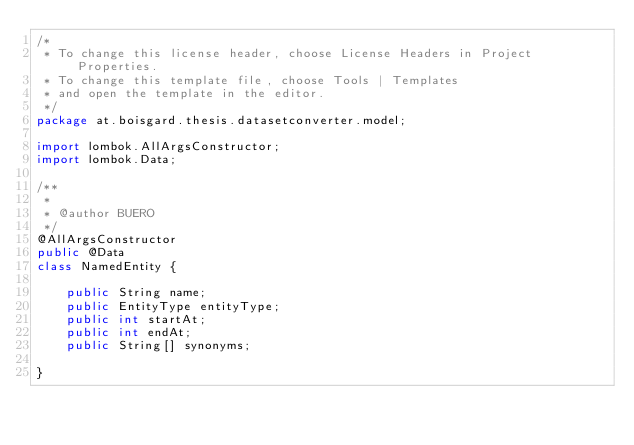Convert code to text. <code><loc_0><loc_0><loc_500><loc_500><_Java_>/*
 * To change this license header, choose License Headers in Project Properties.
 * To change this template file, choose Tools | Templates
 * and open the template in the editor.
 */
package at.boisgard.thesis.datasetconverter.model;

import lombok.AllArgsConstructor;
import lombok.Data;

/**
 *
 * @author BUERO
 */
@AllArgsConstructor
public @Data
class NamedEntity {

    public String name;
    public EntityType entityType;
    public int startAt;
    public int endAt;
    public String[] synonyms;

}
</code> 